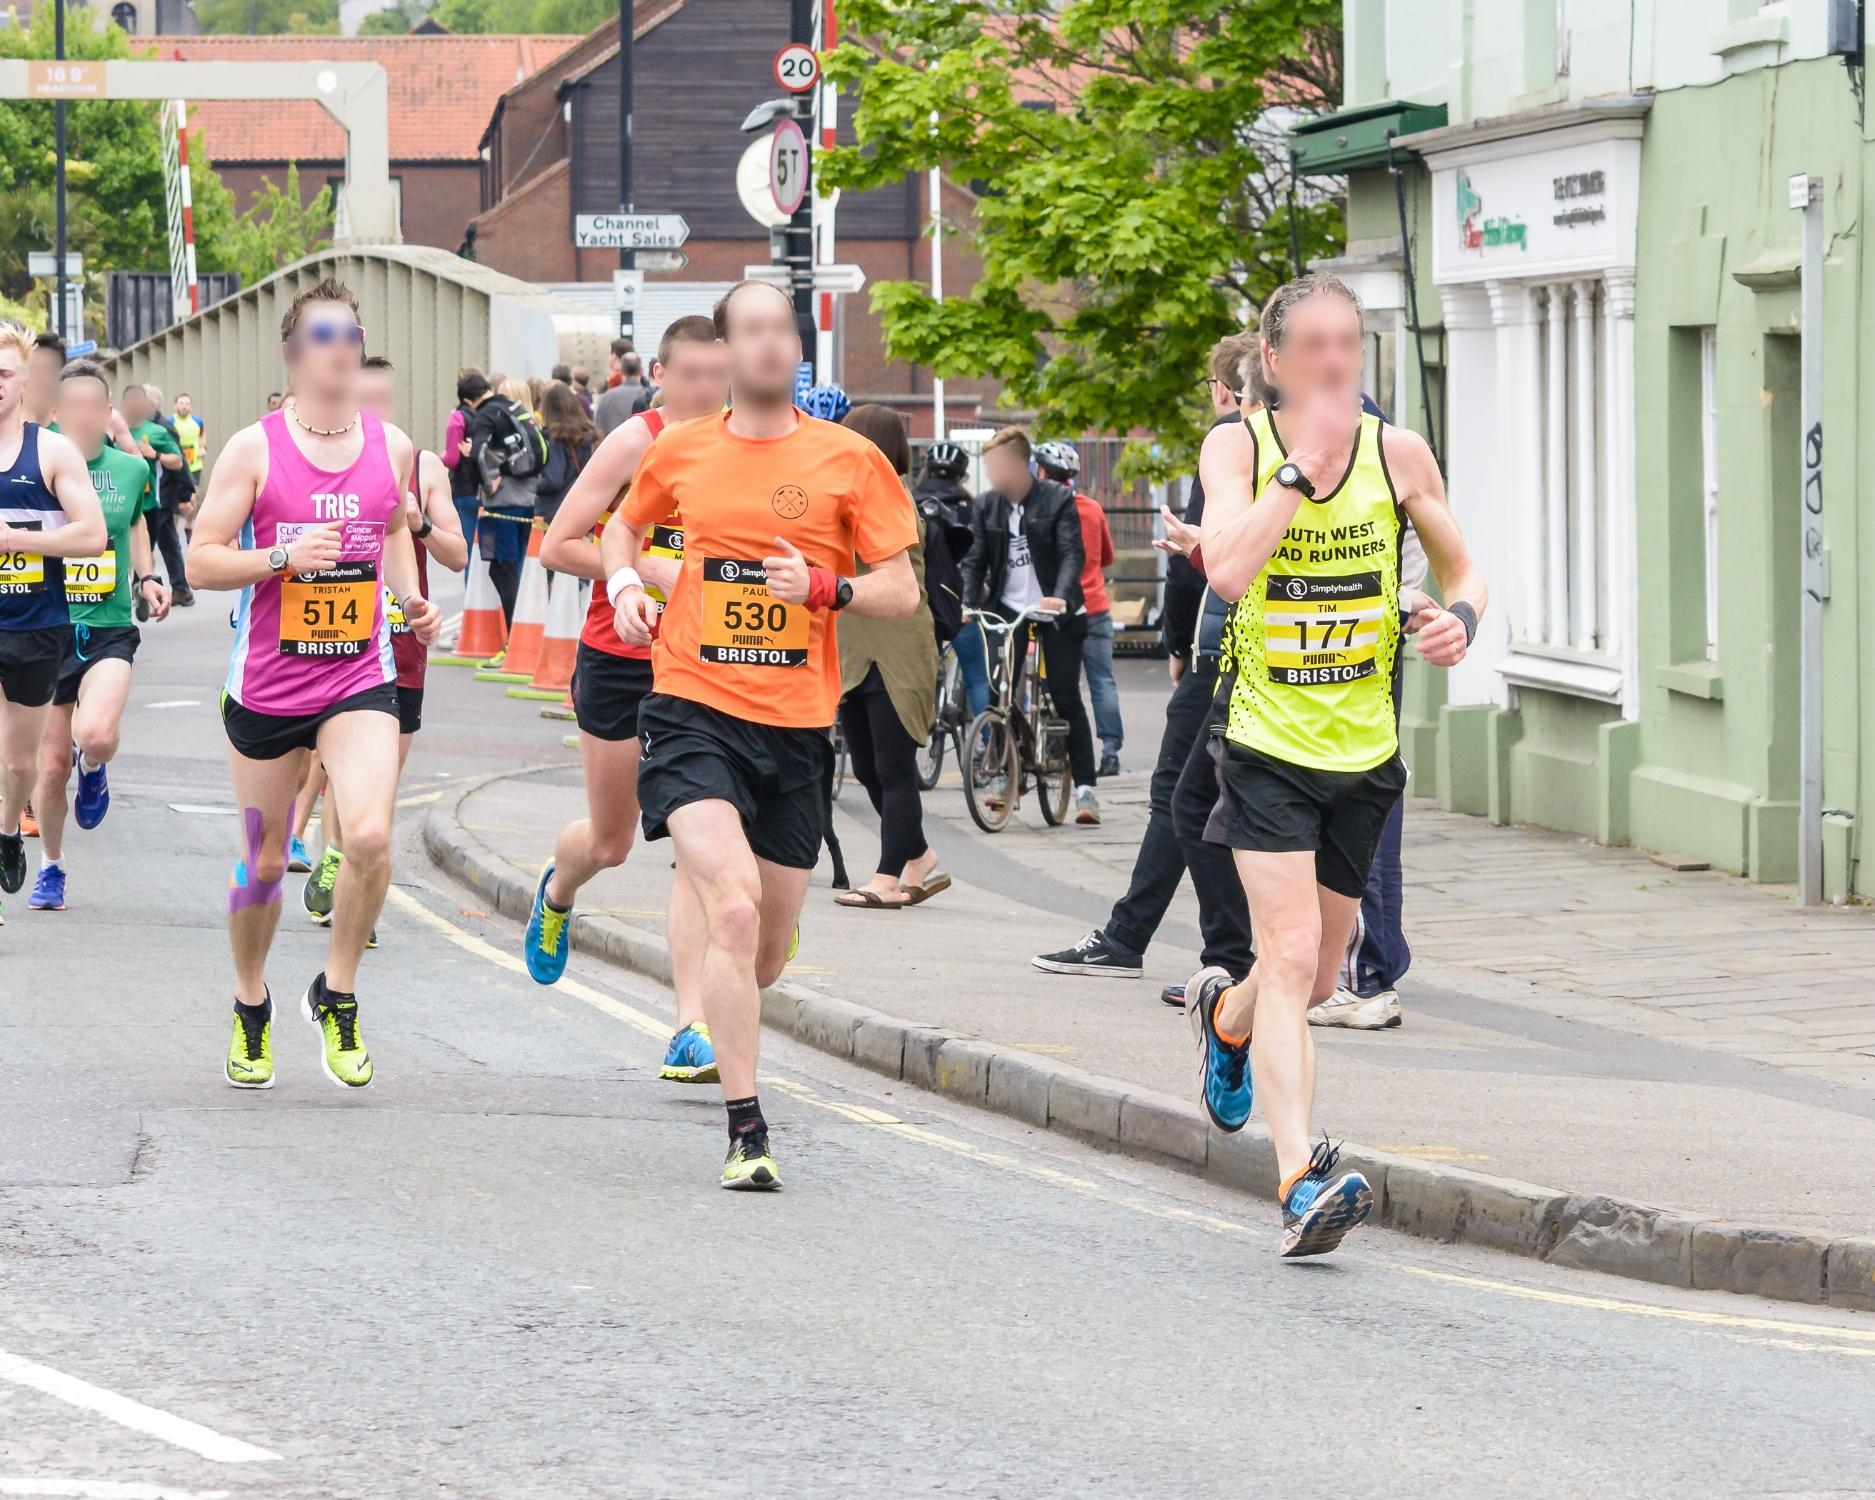Describe the role that the community might play in an event like this. Community plays a critical role in events like street races. It can offer support through volunteers helping to organize the event, local businesses sponsoring or providing amenities, and residents cheering on the runners. Such events often foster a sense of local pride and camaraderie, bringing together participants of all ages and backgrounds to celebrate fitness and community spirit. 